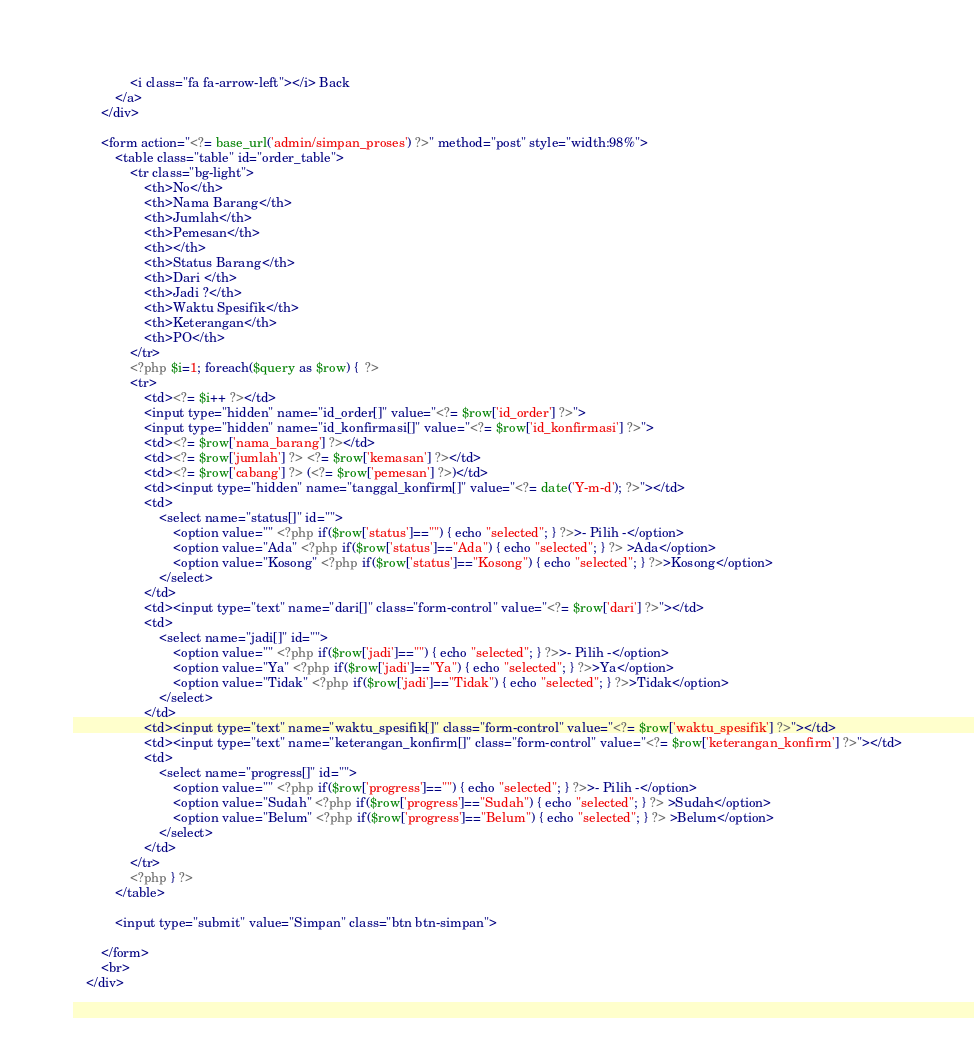<code> <loc_0><loc_0><loc_500><loc_500><_PHP_>				<i class="fa fa-arrow-left"></i> Back
			</a>	
		</div>

		<form action="<?= base_url('admin/simpan_proses') ?>" method="post" style="width:98%">
			<table class="table" id="order_table">
				<tr class="bg-light">
					<th>No</th>
					<th>Nama Barang</th>
					<th>Jumlah</th>
					<th>Pemesan</th>
					<th></th>
					<th>Status Barang</th>
					<th>Dari </th>
					<th>Jadi ?</th>
					<th>Waktu Spesifik</th>
					<th>Keterangan</th>
					<th>PO</th>
				</tr>
				<?php $i=1; foreach($query as $row) {  ?>
				<tr>
					<td><?= $i++ ?></td>
					<input type="hidden" name="id_order[]" value="<?= $row['id_order'] ?>">
					<input type="hidden" name="id_konfirmasi[]" value="<?= $row['id_konfirmasi'] ?>">
					<td><?= $row['nama_barang'] ?></td>
					<td><?= $row['jumlah'] ?> <?= $row['kemasan'] ?></td>
					<td><?= $row['cabang'] ?> (<?= $row['pemesan'] ?>)</td>
					<td><input type="hidden" name="tanggal_konfirm[]" value="<?= date('Y-m-d'); ?>"></td>
					<td>
						<select name="status[]" id="">
							<option value="" <?php if($row['status']=="") { echo "selected"; } ?>>- Pilih -</option>
							<option value="Ada" <?php if($row['status']=="Ada") { echo "selected"; } ?> >Ada</option>
							<option value="Kosong" <?php if($row['status']=="Kosong") { echo "selected"; } ?>>Kosong</option>	
						</select>
					</td>
					<td><input type="text" name="dari[]" class="form-control" value="<?= $row['dari'] ?>"></td>
					<td>
						<select name="jadi[]" id="">
							<option value="" <?php if($row['jadi']=="") { echo "selected"; } ?>>- Pilih -</option>
							<option value="Ya" <?php if($row['jadi']=="Ya") { echo "selected"; } ?>>Ya</option>
							<option value="Tidak" <?php if($row['jadi']=="Tidak") { echo "selected"; } ?>>Tidak</option>	
						</select>
					</td>
					<td><input type="text" name="waktu_spesifik[]" class="form-control" value="<?= $row['waktu_spesifik'] ?>"></td>
					<td><input type="text" name="keterangan_konfirm[]" class="form-control" value="<?= $row['keterangan_konfirm'] ?>"></td>
					<td>
						<select name="progress[]" id="">
							<option value="" <?php if($row['progress']=="") { echo "selected"; } ?>>- Pilih -</option>
							<option value="Sudah" <?php if($row['progress']=="Sudah") { echo "selected"; } ?> >Sudah</option>
							<option value="Belum" <?php if($row['progress']=="Belum") { echo "selected"; } ?> >Belum</option>	
						</select>
					</td>
				</tr>
				<?php } ?>
			</table>
		
			<input type="submit" value="Simpan" class="btn btn-simpan">

		</form>
		<br>
	</div></code> 